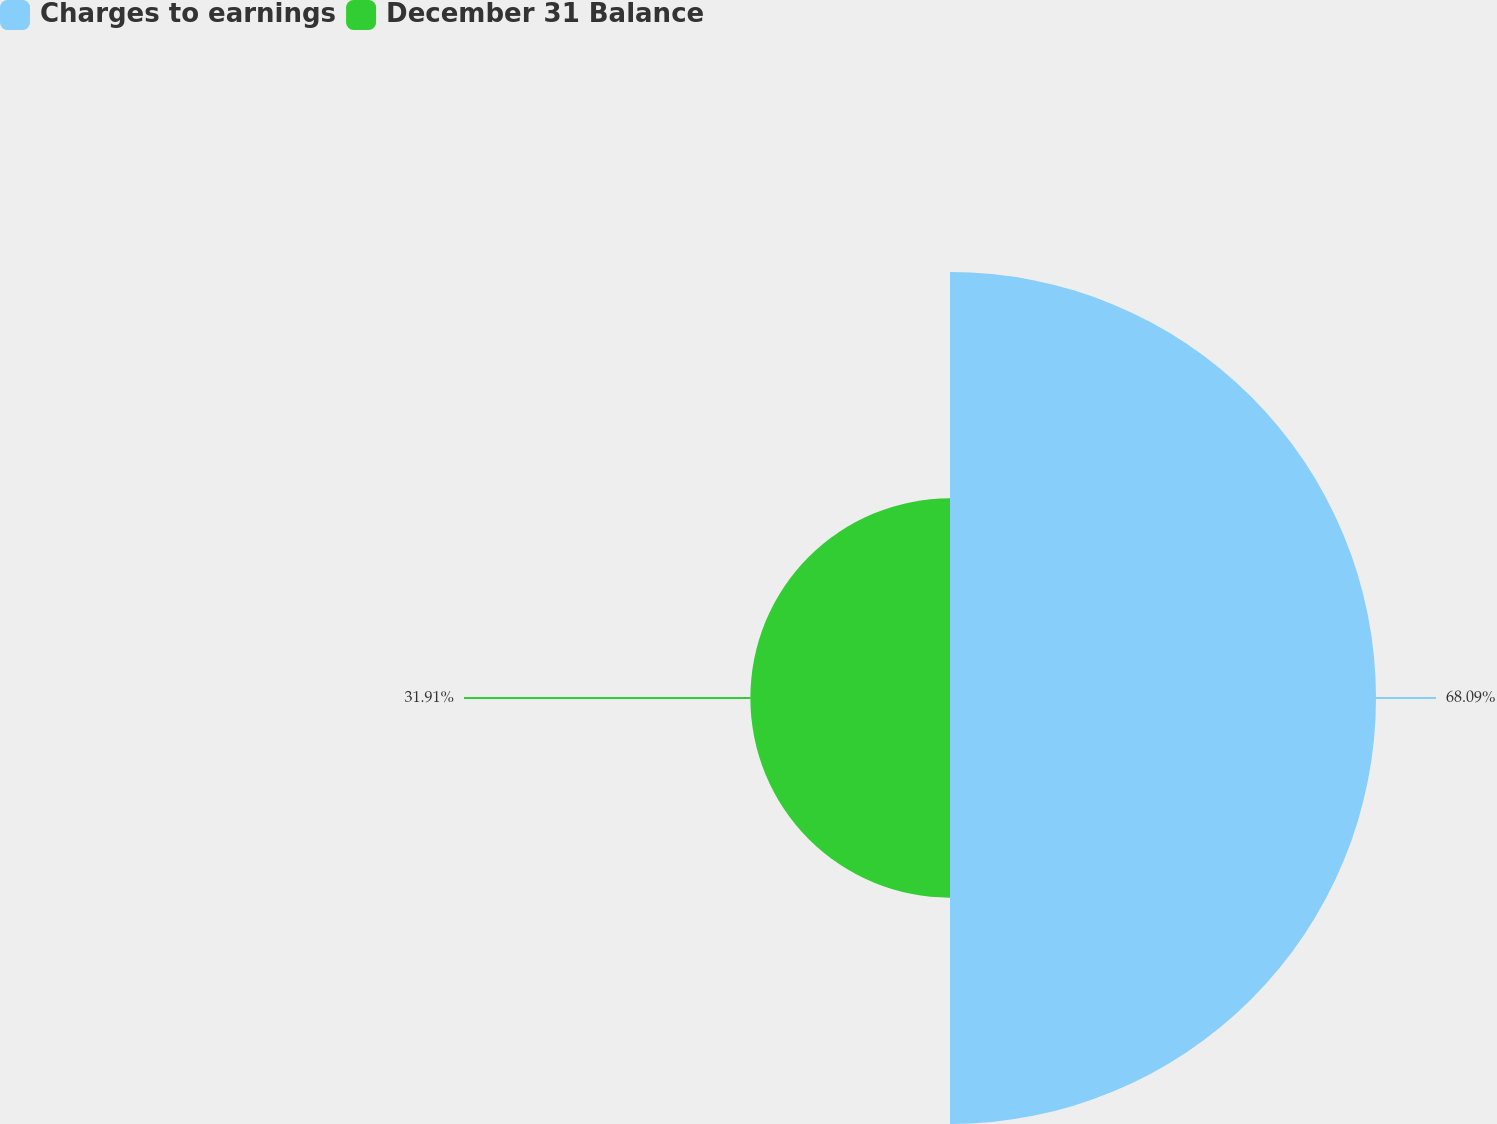Convert chart to OTSL. <chart><loc_0><loc_0><loc_500><loc_500><pie_chart><fcel>Charges to earnings<fcel>December 31 Balance<nl><fcel>68.09%<fcel>31.91%<nl></chart> 